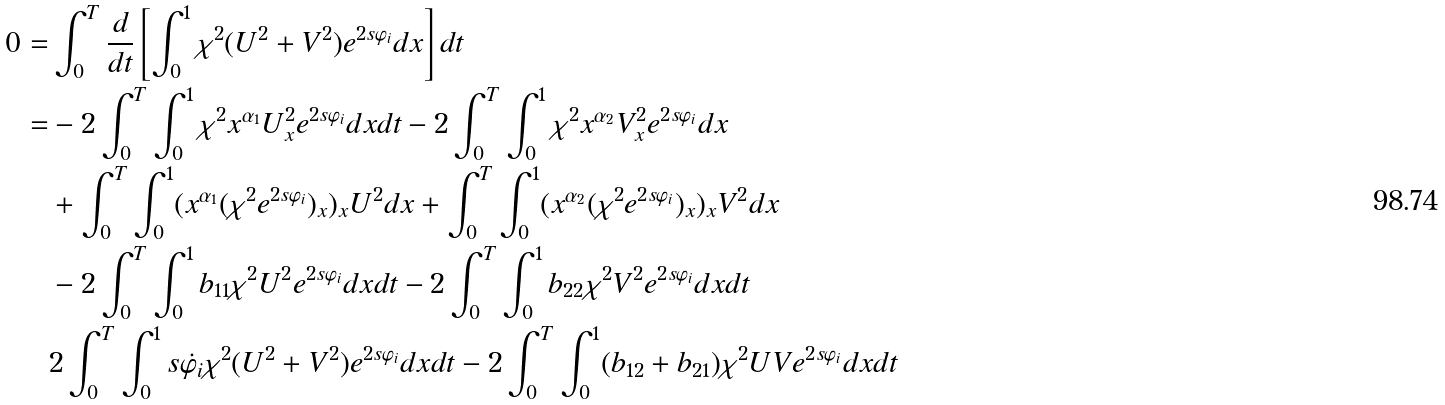Convert formula to latex. <formula><loc_0><loc_0><loc_500><loc_500>0 = & \int _ { 0 } ^ { T } \frac { d } { d t } \left [ \int _ { 0 } ^ { 1 } \chi ^ { 2 } ( U ^ { 2 } + V ^ { 2 } ) e ^ { 2 s \varphi _ { i } } d x \right ] d t \\ = & - 2 \int _ { 0 } ^ { T } \int _ { 0 } ^ { 1 } \chi ^ { 2 } x ^ { \alpha _ { 1 } } U _ { x } ^ { 2 } e ^ { 2 s \varphi _ { i } } d x d t - 2 \int _ { 0 } ^ { T } \int _ { 0 } ^ { 1 } \chi ^ { 2 } x ^ { \alpha _ { 2 } } V _ { x } ^ { 2 } e ^ { 2 s \varphi _ { i } } d x \\ & + \int _ { 0 } ^ { T } \int _ { 0 } ^ { 1 } ( x ^ { \alpha _ { 1 } } ( \chi ^ { 2 } e ^ { 2 s \varphi _ { i } } ) _ { x } ) _ { x } U ^ { 2 } d x + \int _ { 0 } ^ { T } \int _ { 0 } ^ { 1 } ( x ^ { \alpha _ { 2 } } ( \chi ^ { 2 } e ^ { 2 s \varphi _ { i } } ) _ { x } ) _ { x } V ^ { 2 } d x \\ & - 2 \int _ { 0 } ^ { T } \int _ { 0 } ^ { 1 } b _ { 1 1 } \chi ^ { 2 } U ^ { 2 } e ^ { 2 s \varphi _ { i } } d x d t - 2 \int _ { 0 } ^ { T } \int _ { 0 } ^ { 1 } b _ { 2 2 } \chi ^ { 2 } V ^ { 2 } e ^ { 2 s \varphi _ { i } } d x d t \\ & 2 \int _ { 0 } ^ { T } \int _ { 0 } ^ { 1 } s \dot { \varphi _ { i } } \chi ^ { 2 } ( U ^ { 2 } + V ^ { 2 } ) e ^ { 2 s \varphi _ { i } } d x d t - 2 \int _ { 0 } ^ { T } \int _ { 0 } ^ { 1 } ( b _ { 1 2 } + b _ { 2 1 } ) \chi ^ { 2 } U V e ^ { 2 s \varphi _ { i } } d x d t</formula> 